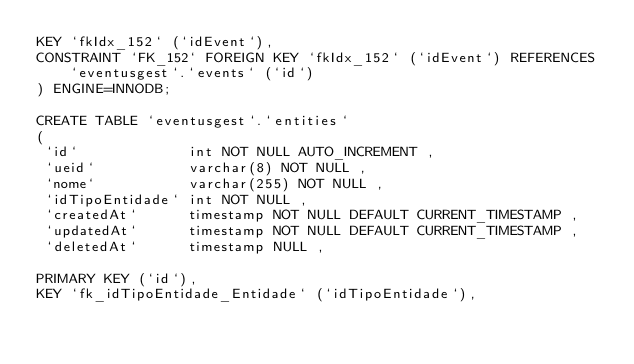Convert code to text. <code><loc_0><loc_0><loc_500><loc_500><_SQL_>KEY `fkIdx_152` (`idEvent`),
CONSTRAINT `FK_152` FOREIGN KEY `fkIdx_152` (`idEvent`) REFERENCES `eventusgest`.`events` (`id`)
) ENGINE=INNODB;

CREATE TABLE `eventusgest`.`entities`
(
 `id`             int NOT NULL AUTO_INCREMENT ,
 `ueid`           varchar(8) NOT NULL ,
 `nome`           varchar(255) NOT NULL ,
 `idTipoEntidade` int NOT NULL ,
 `createdAt`      timestamp NOT NULL DEFAULT CURRENT_TIMESTAMP ,
 `updatedAt`      timestamp NOT NULL DEFAULT CURRENT_TIMESTAMP ,
 `deletedAt`      timestamp NULL ,

PRIMARY KEY (`id`),
KEY `fk_idTipoEntidade_Entidade` (`idTipoEntidade`),</code> 